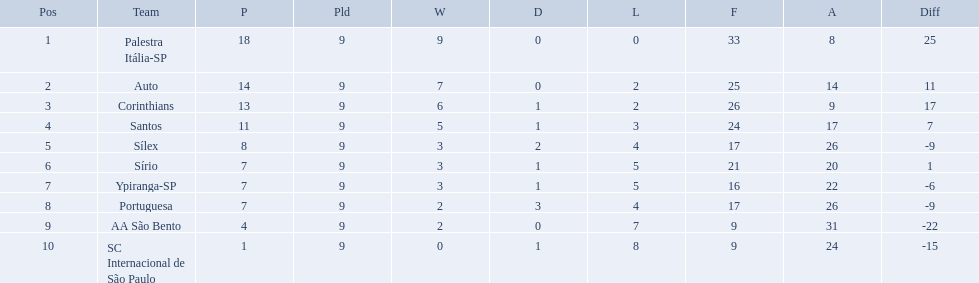How many games did each team play? 9, 9, 9, 9, 9, 9, 9, 9, 9, 9. Did any team score 13 points in the total games they played? 13. What is the name of that team? Corinthians. Which teams were playing brazilian football in 1926? Palestra Itália-SP, Auto, Corinthians, Santos, Sílex, Sírio, Ypiranga-SP, Portuguesa, AA São Bento, SC Internacional de São Paulo. Of those teams, which one scored 13 points? Corinthians. Could you help me parse every detail presented in this table? {'header': ['Pos', 'Team', 'P', 'Pld', 'W', 'D', 'L', 'F', 'A', 'Diff'], 'rows': [['1', 'Palestra Itália-SP', '18', '9', '9', '0', '0', '33', '8', '25'], ['2', 'Auto', '14', '9', '7', '0', '2', '25', '14', '11'], ['3', 'Corinthians', '13', '9', '6', '1', '2', '26', '9', '17'], ['4', 'Santos', '11', '9', '5', '1', '3', '24', '17', '7'], ['5', 'Sílex', '8', '9', '3', '2', '4', '17', '26', '-9'], ['6', 'Sírio', '7', '9', '3', '1', '5', '21', '20', '1'], ['7', 'Ypiranga-SP', '7', '9', '3', '1', '5', '16', '22', '-6'], ['8', 'Portuguesa', '7', '9', '2', '3', '4', '17', '26', '-9'], ['9', 'AA São Bento', '4', '9', '2', '0', '7', '9', '31', '-22'], ['10', 'SC Internacional de São Paulo', '1', '9', '0', '1', '8', '9', '24', '-15']]} Can you parse all the data within this table? {'header': ['Pos', 'Team', 'P', 'Pld', 'W', 'D', 'L', 'F', 'A', 'Diff'], 'rows': [['1', 'Palestra Itália-SP', '18', '9', '9', '0', '0', '33', '8', '25'], ['2', 'Auto', '14', '9', '7', '0', '2', '25', '14', '11'], ['3', 'Corinthians', '13', '9', '6', '1', '2', '26', '9', '17'], ['4', 'Santos', '11', '9', '5', '1', '3', '24', '17', '7'], ['5', 'Sílex', '8', '9', '3', '2', '4', '17', '26', '-9'], ['6', 'Sírio', '7', '9', '3', '1', '5', '21', '20', '1'], ['7', 'Ypiranga-SP', '7', '9', '3', '1', '5', '16', '22', '-6'], ['8', 'Portuguesa', '7', '9', '2', '3', '4', '17', '26', '-9'], ['9', 'AA São Bento', '4', '9', '2', '0', '7', '9', '31', '-22'], ['10', 'SC Internacional de São Paulo', '1', '9', '0', '1', '8', '9', '24', '-15']]} How many teams played football in brazil during the year 1926? Palestra Itália-SP, Auto, Corinthians, Santos, Sílex, Sírio, Ypiranga-SP, Portuguesa, AA São Bento, SC Internacional de São Paulo. What was the highest number of games won during the 1926 season? 9. Which team was in the top spot with 9 wins for the 1926 season? Palestra Itália-SP. Brazilian football in 1926 what teams had no draws? Palestra Itália-SP, Auto, AA São Bento. Of the teams with no draws name the 2 who lost the lease. Palestra Itália-SP, Auto. What team of the 2 who lost the least and had no draws had the highest difference? Palestra Itália-SP. 